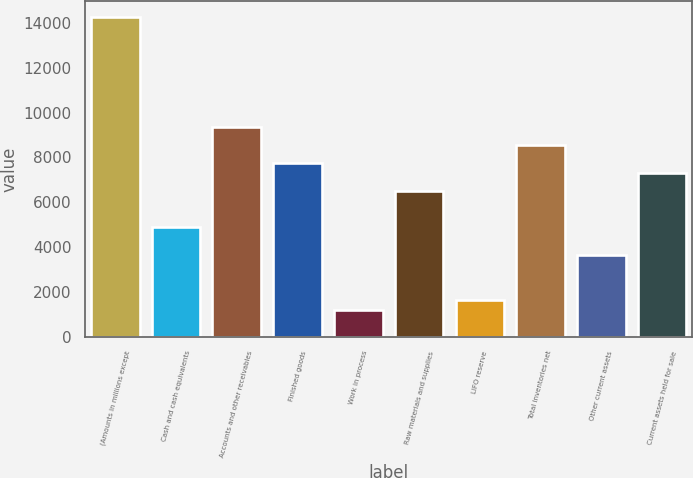<chart> <loc_0><loc_0><loc_500><loc_500><bar_chart><fcel>(Amounts in millions except<fcel>Cash and cash equivalents<fcel>Accounts and other receivables<fcel>Finished goods<fcel>Work in process<fcel>Raw materials and supplies<fcel>LIFO reserve<fcel>Total inventories net<fcel>Other current assets<fcel>Current assets held for sale<nl><fcel>14248.8<fcel>4886.6<fcel>9364.15<fcel>7735.95<fcel>1223.15<fcel>6514.8<fcel>1630.2<fcel>8550.05<fcel>3665.45<fcel>7328.9<nl></chart> 